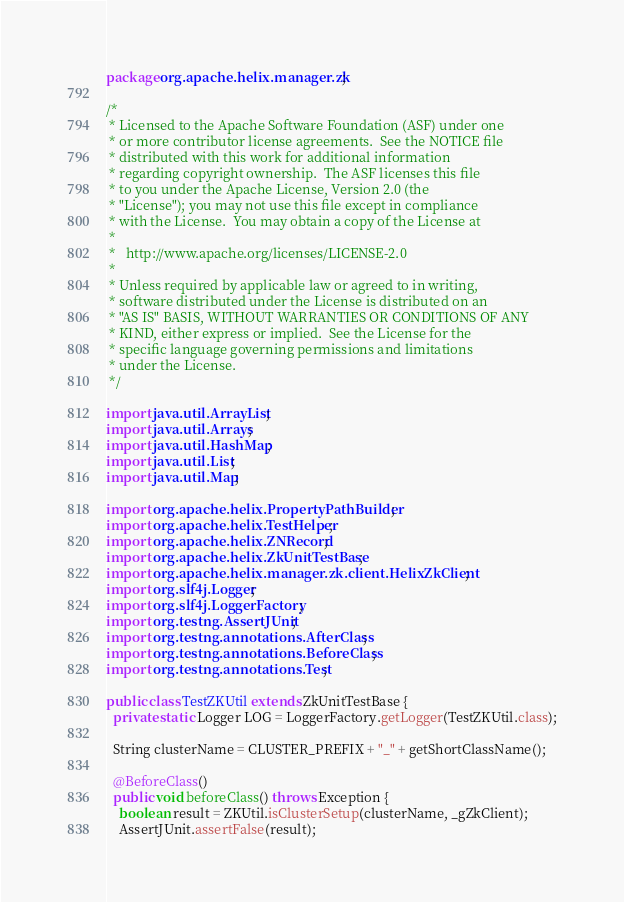Convert code to text. <code><loc_0><loc_0><loc_500><loc_500><_Java_>package org.apache.helix.manager.zk;

/*
 * Licensed to the Apache Software Foundation (ASF) under one
 * or more contributor license agreements.  See the NOTICE file
 * distributed with this work for additional information
 * regarding copyright ownership.  The ASF licenses this file
 * to you under the Apache License, Version 2.0 (the
 * "License"); you may not use this file except in compliance
 * with the License.  You may obtain a copy of the License at
 *
 *   http://www.apache.org/licenses/LICENSE-2.0
 *
 * Unless required by applicable law or agreed to in writing,
 * software distributed under the License is distributed on an
 * "AS IS" BASIS, WITHOUT WARRANTIES OR CONDITIONS OF ANY
 * KIND, either express or implied.  See the License for the
 * specific language governing permissions and limitations
 * under the License.
 */

import java.util.ArrayList;
import java.util.Arrays;
import java.util.HashMap;
import java.util.List;
import java.util.Map;

import org.apache.helix.PropertyPathBuilder;
import org.apache.helix.TestHelper;
import org.apache.helix.ZNRecord;
import org.apache.helix.ZkUnitTestBase;
import org.apache.helix.manager.zk.client.HelixZkClient;
import org.slf4j.Logger;
import org.slf4j.LoggerFactory;
import org.testng.AssertJUnit;
import org.testng.annotations.AfterClass;
import org.testng.annotations.BeforeClass;
import org.testng.annotations.Test;

public class TestZKUtil extends ZkUnitTestBase {
  private static Logger LOG = LoggerFactory.getLogger(TestZKUtil.class);

  String clusterName = CLUSTER_PREFIX + "_" + getShortClassName();

  @BeforeClass()
  public void beforeClass() throws Exception {
    boolean result = ZKUtil.isClusterSetup(clusterName, _gZkClient);
    AssertJUnit.assertFalse(result);</code> 